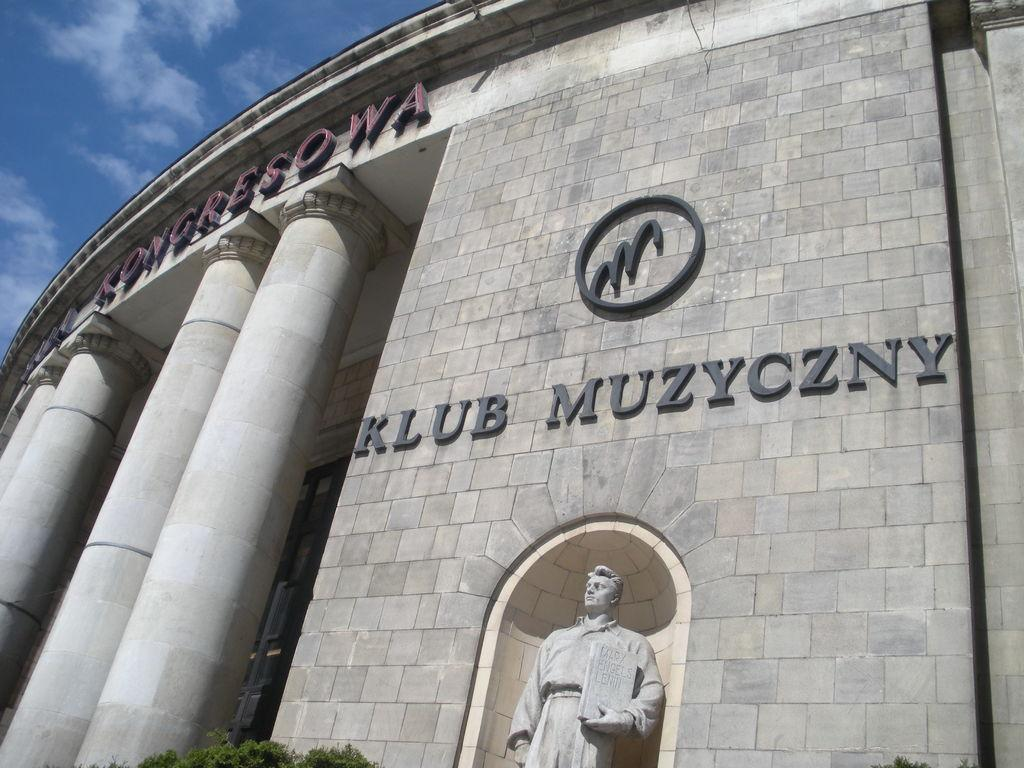What type of structure is present in the image? There is a building in the image. What architectural feature can be seen at the front of the building? The building has four pillars in front. What is the statue in the image depicting? The statue is of a person holding a book in his hand. What can be seen in the background of the image? There are trees and the sky visible in the background of the image. What type of spark can be seen coming from the book held by the statue? There is no spark present in the image; the statue is holding a book without any visible sparks. What type of oatmeal is being served at the building in the image? There is no mention of oatmeal or any food being served in the image; it primarily features a building, pillars, a statue, trees, and the sky. 